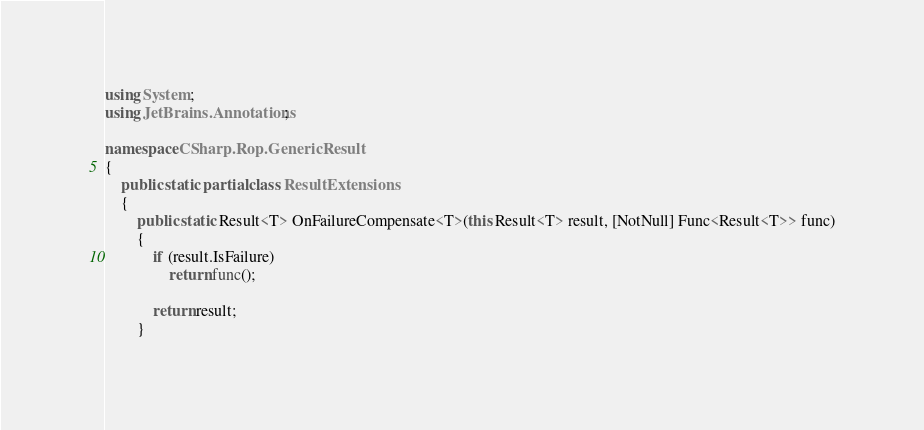Convert code to text. <code><loc_0><loc_0><loc_500><loc_500><_C#_>using System;
using JetBrains.Annotations;

namespace CSharp.Rop.GenericResult
{
    public static partial class ResultExtensions
    {
        public static Result<T> OnFailureCompensate<T>(this Result<T> result, [NotNull] Func<Result<T>> func)
        {
            if (result.IsFailure)
                return func();

            return result;
        }
</code> 